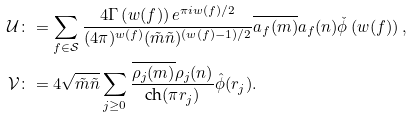Convert formula to latex. <formula><loc_0><loc_0><loc_500><loc_500>\mathcal { U } & \colon = \sum _ { f \in \mathcal { S } } \frac { 4 \Gamma \left ( w ( f ) \right ) e ^ { \pi i w ( f ) / 2 } } { ( 4 \pi ) ^ { w ( f ) } ( \tilde { m } \tilde { n } ) ^ { ( w ( f ) - 1 ) / 2 } } \overline { a _ { f } ( m ) } a _ { f } ( n ) \check { \phi } \left ( w ( f ) \right ) , \\ \mathcal { V } & \colon = 4 \sqrt { \tilde { m } \tilde { n } } \sum _ { j \geq 0 } \frac { \overline { \rho _ { j } ( m ) } \rho _ { j } ( n ) } { \text {ch} ( \pi r _ { j } ) } \hat { \phi } ( r _ { j } ) .</formula> 